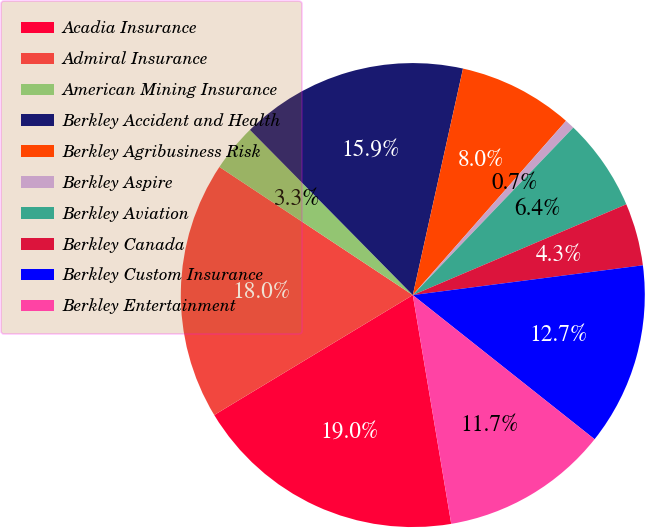Convert chart. <chart><loc_0><loc_0><loc_500><loc_500><pie_chart><fcel>Acadia Insurance<fcel>Admiral Insurance<fcel>American Mining Insurance<fcel>Berkley Accident and Health<fcel>Berkley Agribusiness Risk<fcel>Berkley Aspire<fcel>Berkley Aviation<fcel>Berkley Canada<fcel>Berkley Custom Insurance<fcel>Berkley Entertainment<nl><fcel>19.0%<fcel>17.96%<fcel>3.3%<fcel>15.86%<fcel>8.01%<fcel>0.68%<fcel>6.44%<fcel>4.35%<fcel>12.72%<fcel>11.68%<nl></chart> 